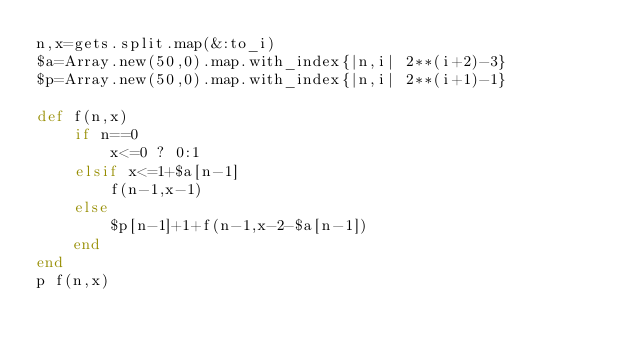Convert code to text. <code><loc_0><loc_0><loc_500><loc_500><_Ruby_>n,x=gets.split.map(&:to_i)
$a=Array.new(50,0).map.with_index{|n,i| 2**(i+2)-3}
$p=Array.new(50,0).map.with_index{|n,i| 2**(i+1)-1}

def f(n,x)
    if n==0
        x<=0 ? 0:1
    elsif x<=1+$a[n-1]
        f(n-1,x-1)
    else
        $p[n-1]+1+f(n-1,x-2-$a[n-1])
    end
end
p f(n,x)

</code> 